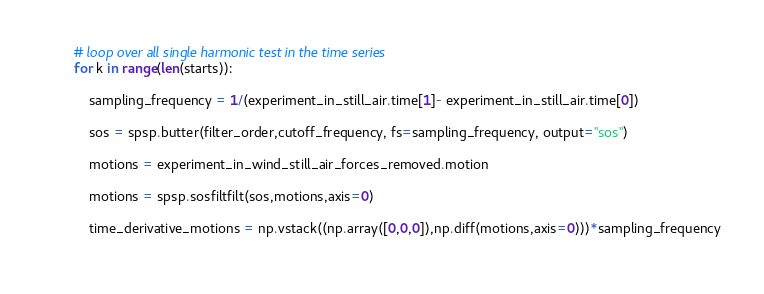Convert code to text. <code><loc_0><loc_0><loc_500><loc_500><_Python_>        # loop over all single harmonic test in the time series
        for k in range(len(starts)):           

            sampling_frequency = 1/(experiment_in_still_air.time[1]- experiment_in_still_air.time[0])
       
            sos = spsp.butter(filter_order,cutoff_frequency, fs=sampling_frequency, output="sos")
           
            motions = experiment_in_wind_still_air_forces_removed.motion
            
            motions = spsp.sosfiltfilt(sos,motions,axis=0)
            
            time_derivative_motions = np.vstack((np.array([0,0,0]),np.diff(motions,axis=0)))*sampling_frequency
            </code> 